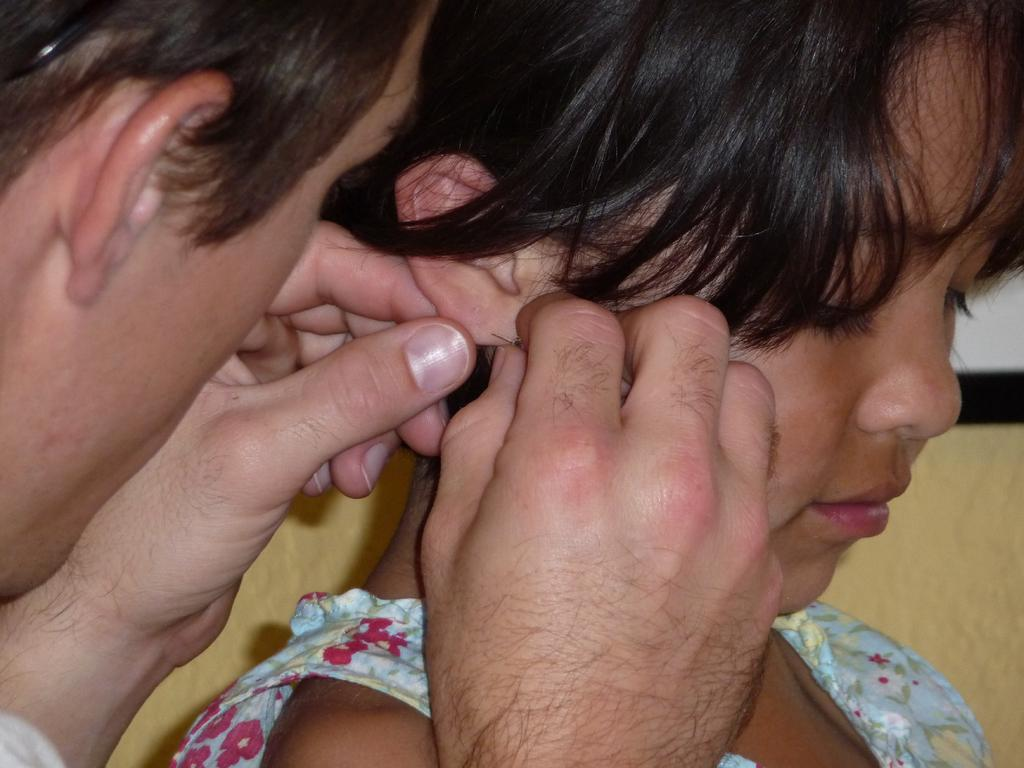How many people are in the image? There are two persons visible in the image. What is one of the persons holding? One person is holding a needle. What type of fish can be seen swimming in the image? There are no fish present in the image; it features two persons, one of whom is holding a needle. 